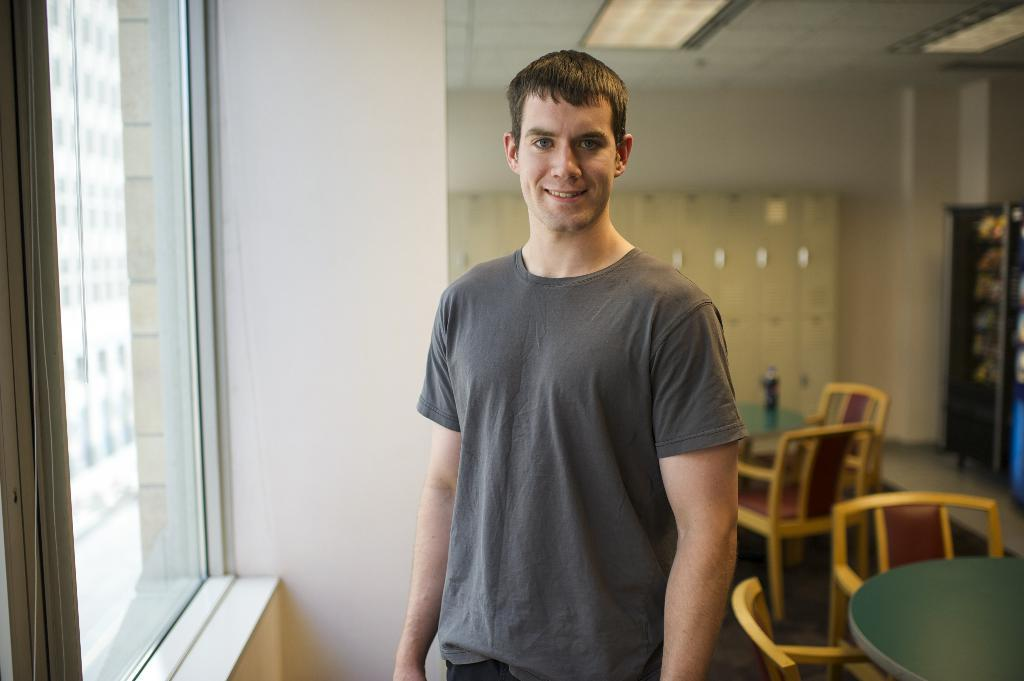What is the main subject of the image? There is a man in the image. What is the man doing in the image? The man is standing and smiling. What objects can be seen in the background of the image? There is a chair, a table, a rack, and a window in the background of the image. What type of pollution can be seen coming from the man's mouth in the image? There is no pollution visible in the image, and the man's mouth is not depicted as emitting any substance. Can you tell me how many clams are on the table in the image? There are no clams present in the image; the table and other objects are not associated with clams. 